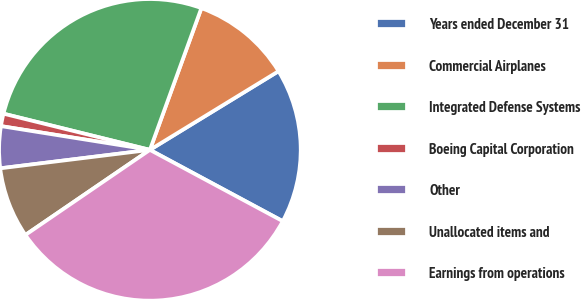Convert chart. <chart><loc_0><loc_0><loc_500><loc_500><pie_chart><fcel>Years ended December 31<fcel>Commercial Airplanes<fcel>Integrated Defense Systems<fcel>Boeing Capital Corporation<fcel>Other<fcel>Unallocated items and<fcel>Earnings from operations<nl><fcel>16.58%<fcel>10.72%<fcel>26.69%<fcel>1.34%<fcel>4.47%<fcel>7.59%<fcel>32.62%<nl></chart> 